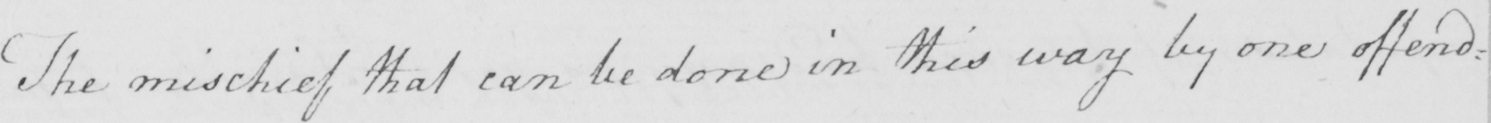Can you read and transcribe this handwriting? The mischief that can be done in this way by one offend= 